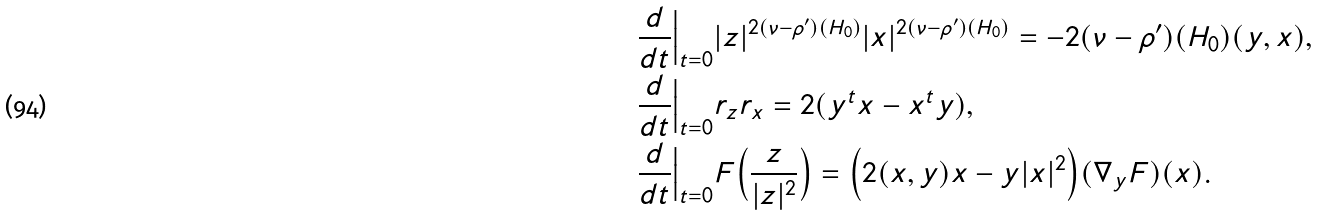<formula> <loc_0><loc_0><loc_500><loc_500>& \frac { d } { d t } \Big | _ { t = 0 } | z | ^ { 2 ( \nu - \rho ^ { \prime } ) ( H _ { 0 } ) } | x | ^ { 2 ( \nu - \rho ^ { \prime } ) ( H _ { 0 } ) } = - 2 ( \nu - \rho ^ { \prime } ) ( H _ { 0 } ) ( y , x ) , \\ & \frac { d } { d t } \Big | _ { t = 0 } r _ { z } r _ { x } = 2 ( y ^ { t } x - x ^ { t } y ) , \\ & \frac { d } { d t } \Big | _ { t = 0 } F \Big ( \frac { z } { | z | ^ { 2 } } \Big ) = \Big ( 2 ( x , y ) x - y | x | ^ { 2 } \Big ) ( \nabla _ { y } F ) ( x ) .</formula> 